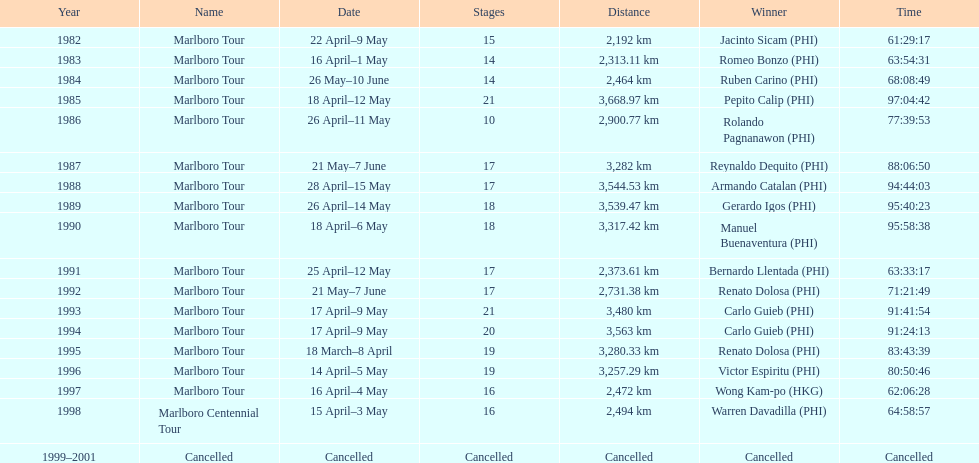Who comes before wong kam-po in the list? Victor Espiritu (PHI). 